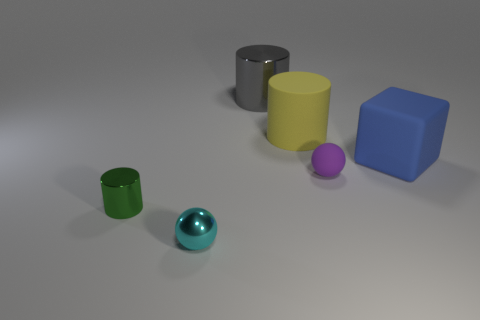Add 4 tiny green matte cylinders. How many objects exist? 10 Subtract all blocks. How many objects are left? 5 Subtract all large yellow things. Subtract all tiny gray rubber blocks. How many objects are left? 5 Add 4 blocks. How many blocks are left? 5 Add 6 purple spheres. How many purple spheres exist? 7 Subtract 0 blue cylinders. How many objects are left? 6 